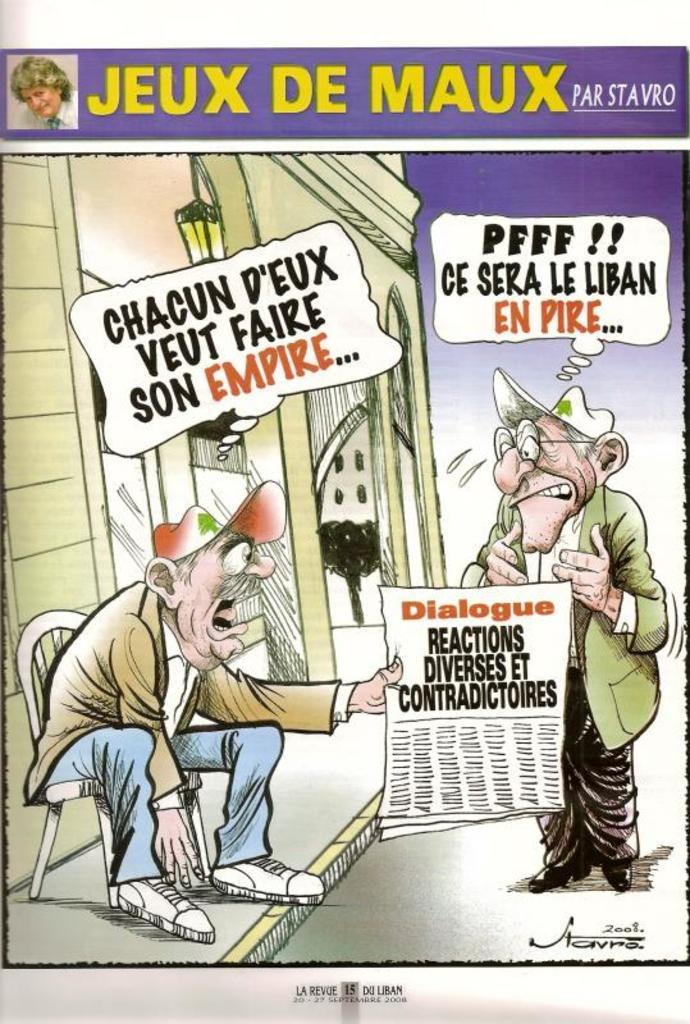What is the man in the foreground of the image doing? There is a man sitting on a chair in the foreground of the image, and he is holding a paper in his hand. Can you describe the other person in the foreground of the image? There is another man standing in the foreground of the image. What is present on the top of the image? There are dialogue boxes on the top of the image. How many police officers are visible in the image? There are no police officers present in the image. What is the color of the tongue of the man sitting on the chair? There is no mention of a tongue in the image, and therefore its color cannot be determined. 